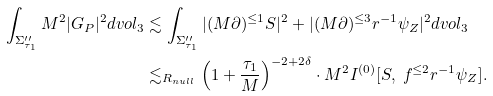Convert formula to latex. <formula><loc_0><loc_0><loc_500><loc_500>\int _ { \Sigma ^ { \prime \prime } _ { \tau _ { 1 } } } M ^ { 2 } | G _ { P } | ^ { 2 } d v o l _ { 3 } & \lesssim \int _ { \Sigma ^ { \prime \prime } _ { \tau _ { 1 } } } | ( M \partial ) ^ { \leq 1 } S | ^ { 2 } + | ( M \partial ) ^ { \leq 3 } r ^ { - 1 } \psi _ { Z } | ^ { 2 } d v o l _ { 3 } \\ & \lesssim _ { R _ { n u l l } } \left ( 1 + \frac { \tau _ { 1 } } { M } \right ) ^ { - 2 + 2 \delta } \cdot M ^ { 2 } I ^ { ( 0 ) } [ S , \ f ^ { \leq 2 } r ^ { - 1 } \psi _ { Z } ] .</formula> 